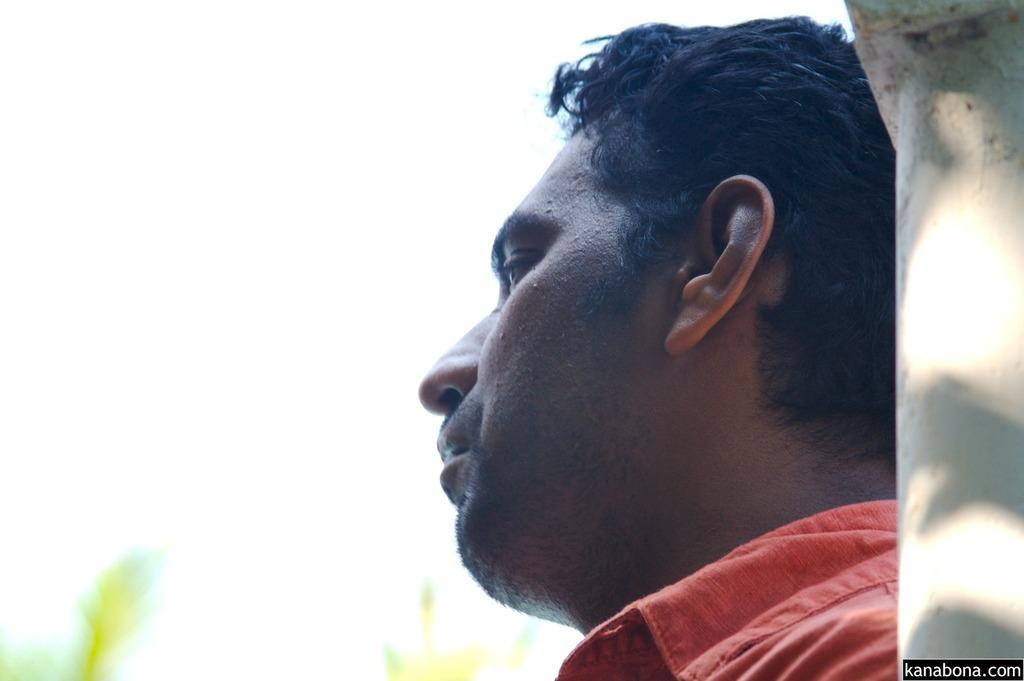In one or two sentences, can you explain what this image depicts? In this image we can see there is a person looking at the left side of the image, behind him there is like a wall. The background is blurred. 